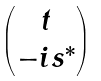<formula> <loc_0><loc_0><loc_500><loc_500>\begin{pmatrix} t \\ - i s ^ { * } \end{pmatrix}</formula> 